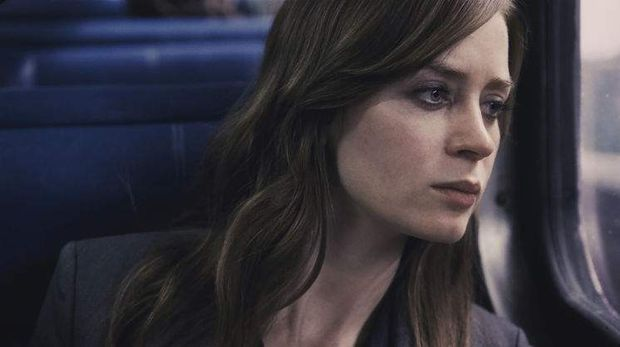Can you elaborate on the elements of the picture provided?
 In this image, we see Emily Blunt, portraying the character of Rachel Watson from the movie "The Girl on the Train". She is seated inside a train, her gaze directed out of the window, a thoughtful expression on her face. Her hair, styled in loose waves, adds to the contemplative mood. She is dressed in a gray blazer, which blends with the predominantly blue and gray tones of the image. The setting and her attire suggest a cool, possibly overcast day. The image captures a moment of introspection, as if she is lost in thought while journeying on the train. 